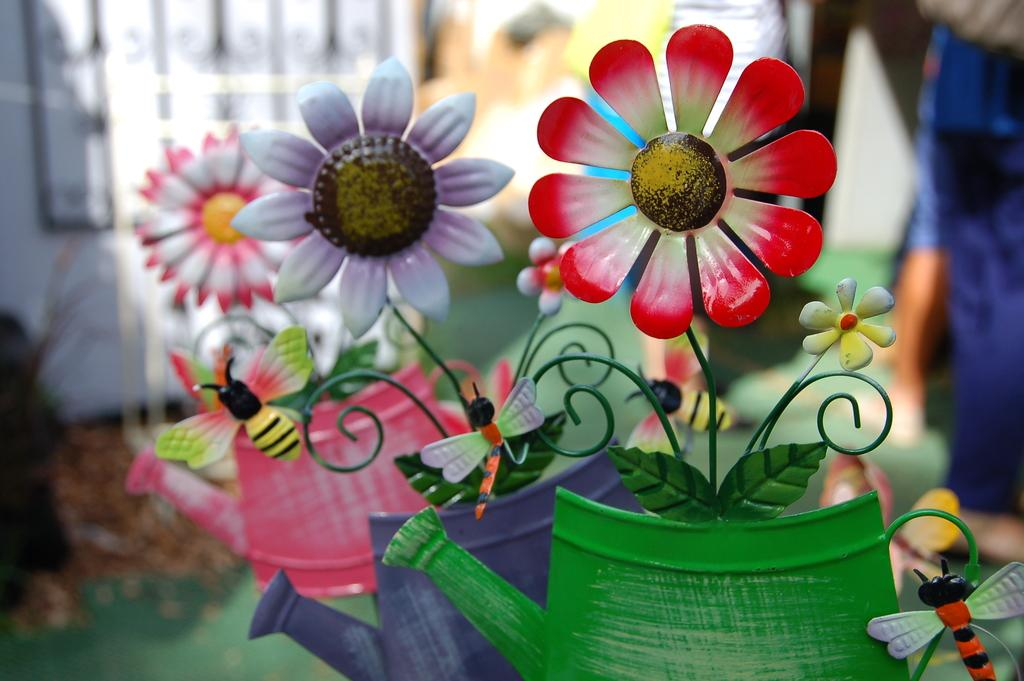What type of plants can be seen in the image? There are flowers in the image. What colors are the flowers in the image? The flowers are in red, white, purple, and green colors. Can you describe the background of the image? The background of the image is blurred. What objects are related to watering the flowers in the image? There are water cans visible in the image. What type of belief is represented by the flowers in the image? There is no indication of any belief being represented by the flowers in the image. 